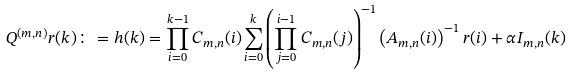Convert formula to latex. <formula><loc_0><loc_0><loc_500><loc_500>Q ^ { ( m , n ) } r ( k ) \colon = h ( k ) = \prod _ { i = 0 } ^ { k - 1 } C _ { m , n } ( i ) \sum _ { i = 0 } ^ { k } \left ( \prod _ { j = 0 } ^ { i - 1 } C _ { m , n } ( j ) \right ) ^ { - 1 } \left ( A _ { m , n } ( i ) \right ) ^ { - 1 } r ( i ) + \alpha I _ { m , n } ( k )</formula> 